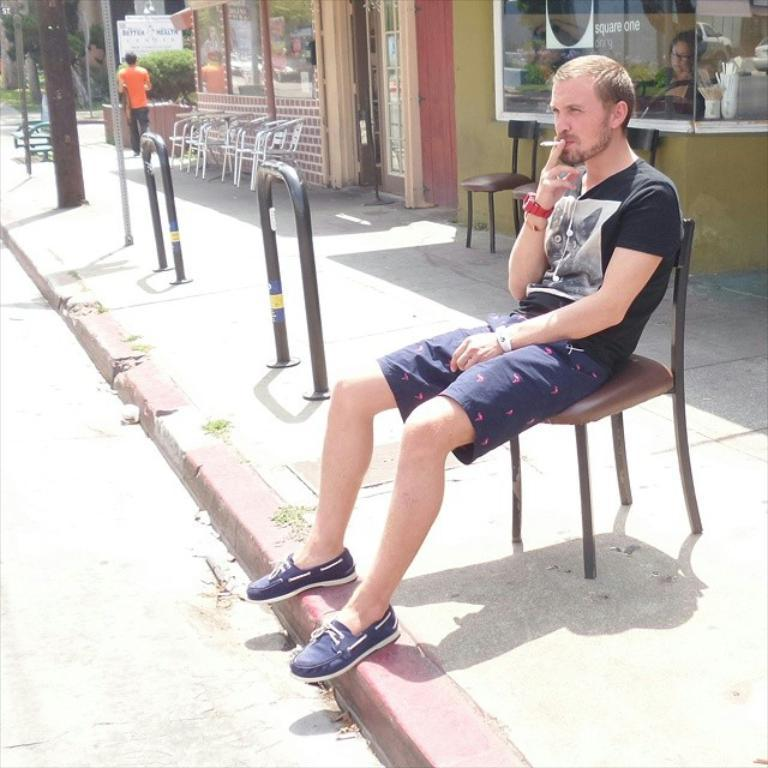What is the person in the image doing? The person is sitting on a chair in the image. What is the person holding in their hand? The person is holding a cigarette in their hand. What can be seen in the background of the image? There are chairs, a person walking, plants, a door, and an electric pole in the background of the image. How far away is the pet from the person in the image? There is no pet present in the image, so it is not possible to determine the distance between a pet and the person. 